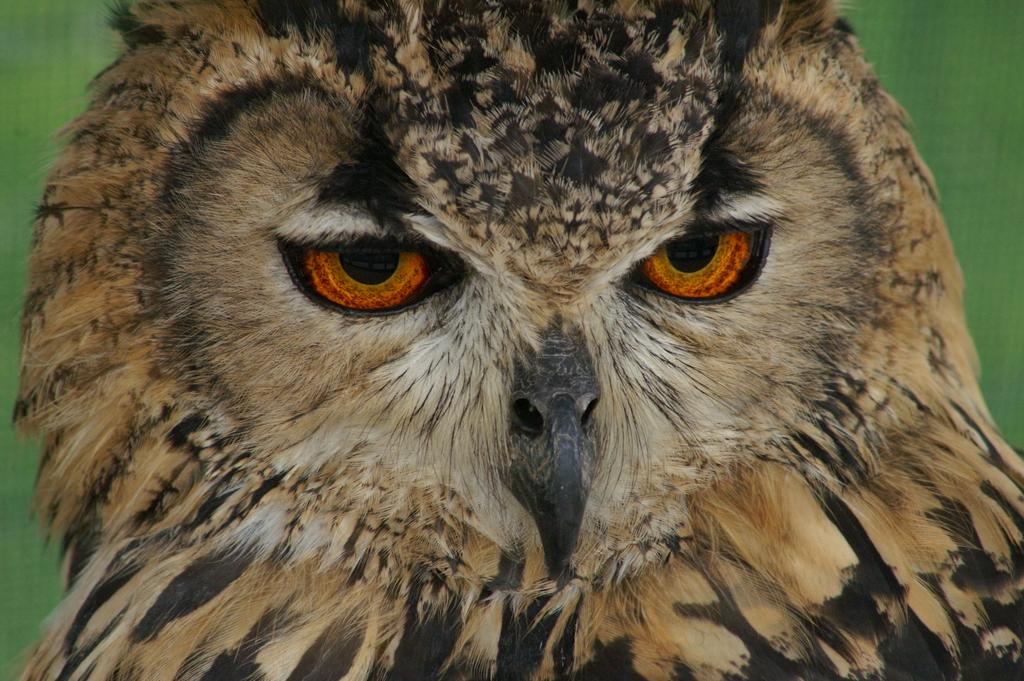What animal is in the picture? There is an owl in the picture. What color is the background of the image? The background of the image is green. What type of juice is being served by the governor in the image? There is no governor or juice present in the image; it only features an owl and a green background. 